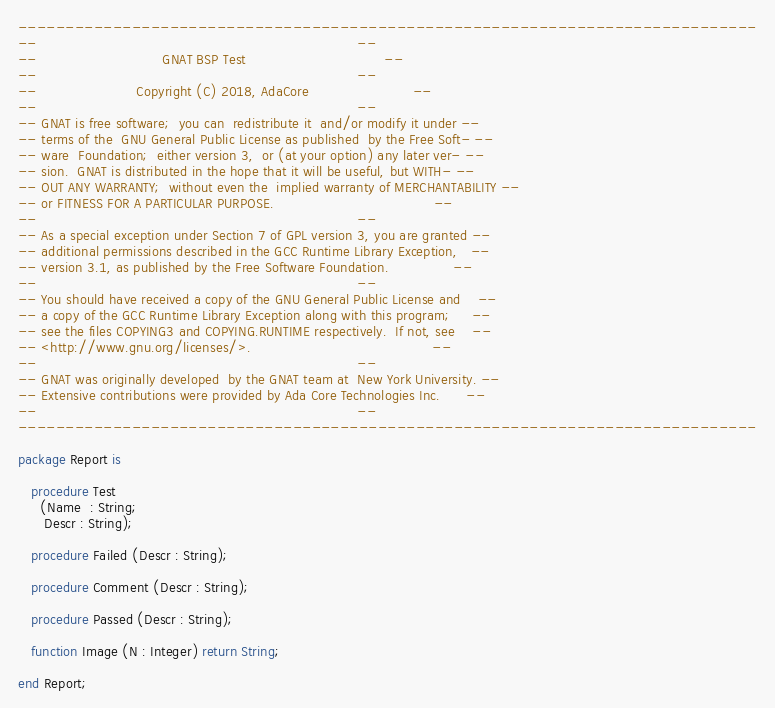<code> <loc_0><loc_0><loc_500><loc_500><_Ada_>------------------------------------------------------------------------------
--                                                                          --
--                             GNAT BSP Test                                --
--                                                                          --
--                       Copyright (C) 2018, AdaCore                        --
--                                                                          --
-- GNAT is free software;  you can  redistribute it  and/or modify it under --
-- terms of the  GNU General Public License as published  by the Free Soft- --
-- ware  Foundation;  either version 3,  or (at your option) any later ver- --
-- sion.  GNAT is distributed in the hope that it will be useful, but WITH- --
-- OUT ANY WARRANTY;  without even the  implied warranty of MERCHANTABILITY --
-- or FITNESS FOR A PARTICULAR PURPOSE.                                     --
--                                                                          --
-- As a special exception under Section 7 of GPL version 3, you are granted --
-- additional permissions described in the GCC Runtime Library Exception,   --
-- version 3.1, as published by the Free Software Foundation.               --
--                                                                          --
-- You should have received a copy of the GNU General Public License and    --
-- a copy of the GCC Runtime Library Exception along with this program;     --
-- see the files COPYING3 and COPYING.RUNTIME respectively.  If not, see    --
-- <http://www.gnu.org/licenses/>.                                          --
--                                                                          --
-- GNAT was originally developed  by the GNAT team at  New York University. --
-- Extensive contributions were provided by Ada Core Technologies Inc.      --
--                                                                          --
------------------------------------------------------------------------------

package Report is

   procedure Test
     (Name  : String;
      Descr : String);

   procedure Failed (Descr : String);

   procedure Comment (Descr : String);

   procedure Passed (Descr : String);

   function Image (N : Integer) return String;

end Report;
</code> 